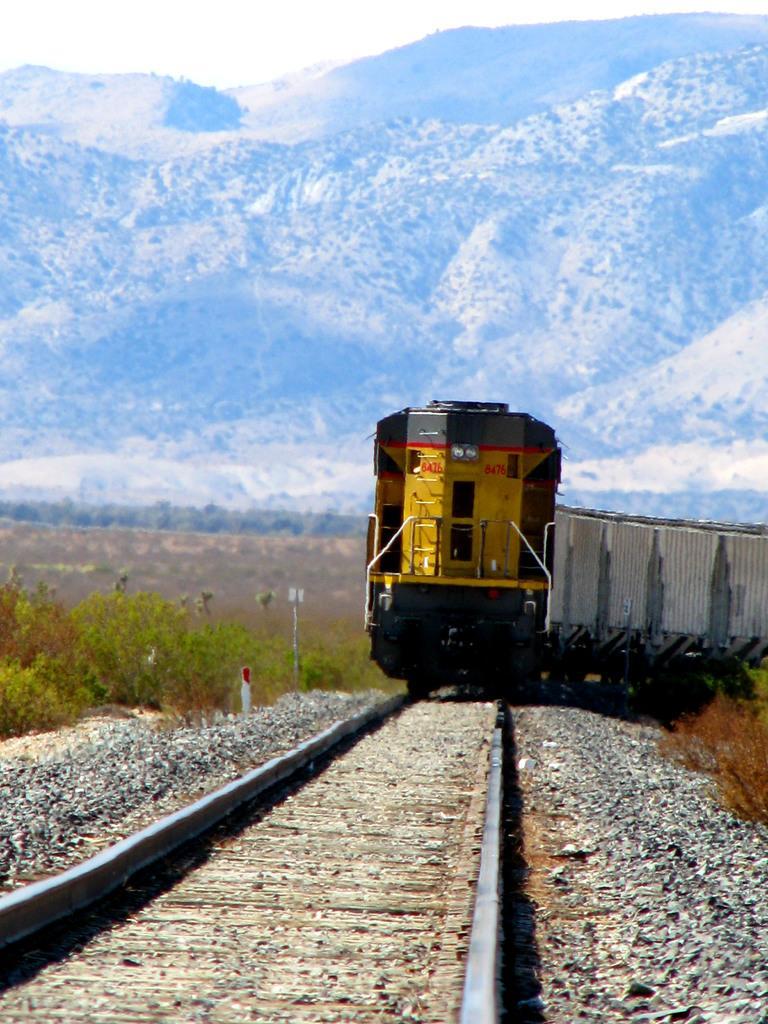Please provide a concise description of this image. This is an outside view. In this image I can see a train on the railway track. On both sides of the track I can see the stones. In the background there are some plants. At the top there are few hills. 